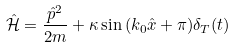<formula> <loc_0><loc_0><loc_500><loc_500>\hat { \mathcal { H } } = \frac { \hat { p } ^ { 2 } } { 2 m } + \kappa \sin { ( k _ { 0 } \hat { x } + \pi ) } \delta _ { T } ( t )</formula> 